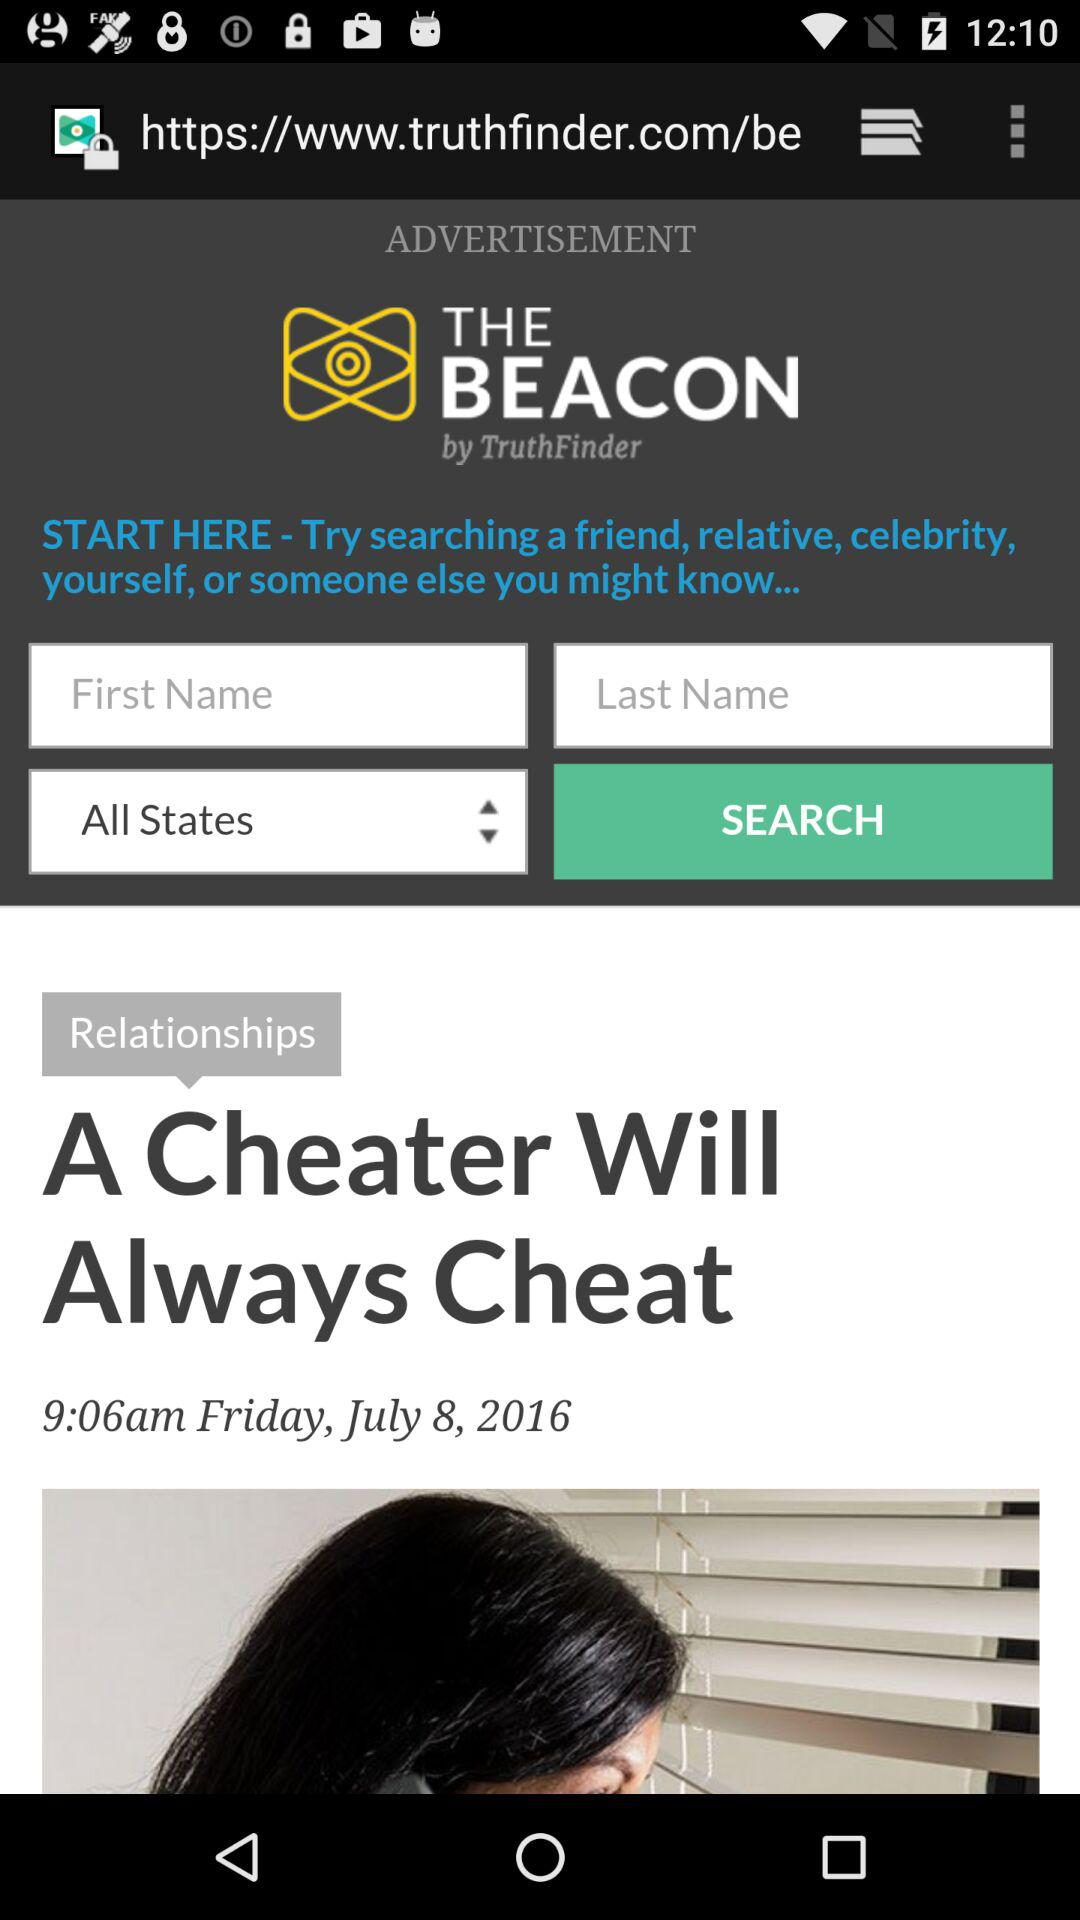Who is the author of "A Cheater Will Always Cheat"?
When the provided information is insufficient, respond with <no answer>. <no answer> 